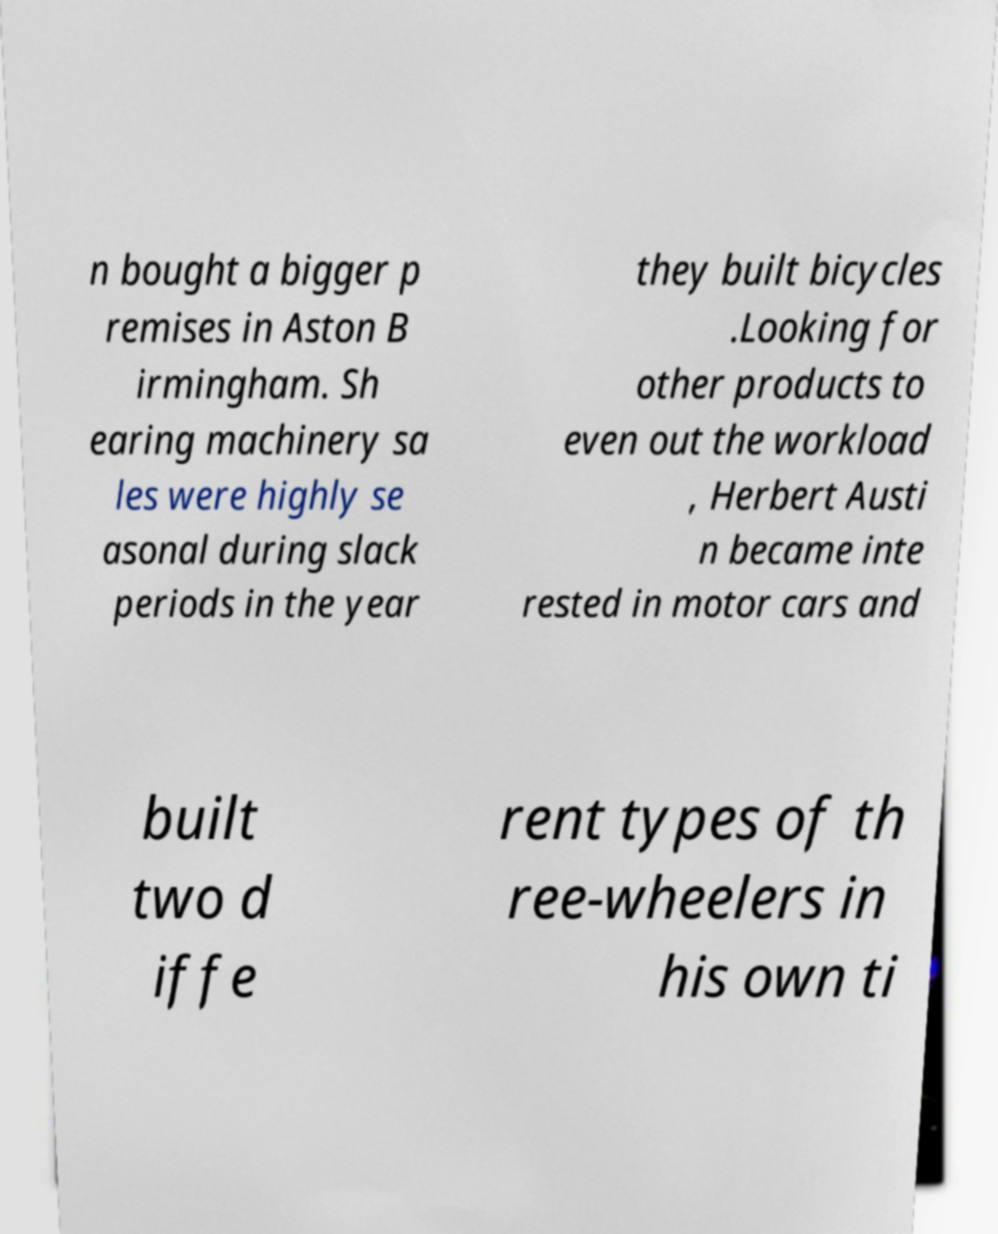There's text embedded in this image that I need extracted. Can you transcribe it verbatim? n bought a bigger p remises in Aston B irmingham. Sh earing machinery sa les were highly se asonal during slack periods in the year they built bicycles .Looking for other products to even out the workload , Herbert Austi n became inte rested in motor cars and built two d iffe rent types of th ree-wheelers in his own ti 